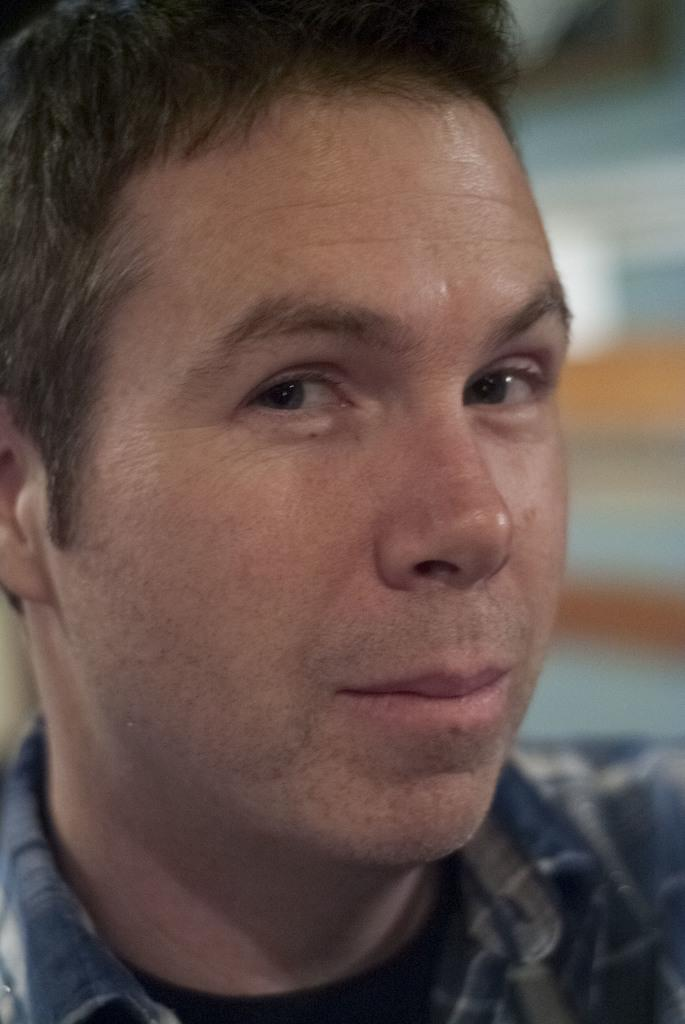What is the main subject of the image? There is a person in the image. Can you describe the person's attire? The person is wearing a blue and black color dress. How would you describe the background of the image? The background of the image is blurred. What type of cake is the person learning to bake in the image? There is no cake or indication of learning in the image; it only features a person wearing a blue and black color dress with a blurred background. 